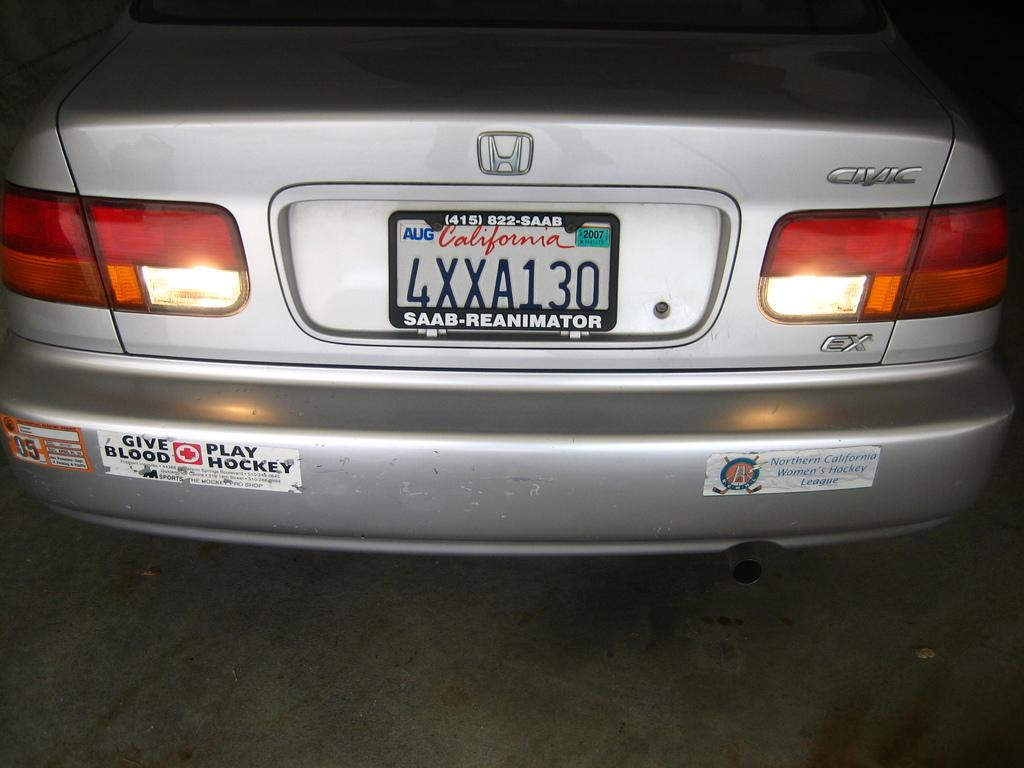<image>
Create a compact narrative representing the image presented. The rear end of a silver Honda Civic has a give blood play hockey bumper sticker. 